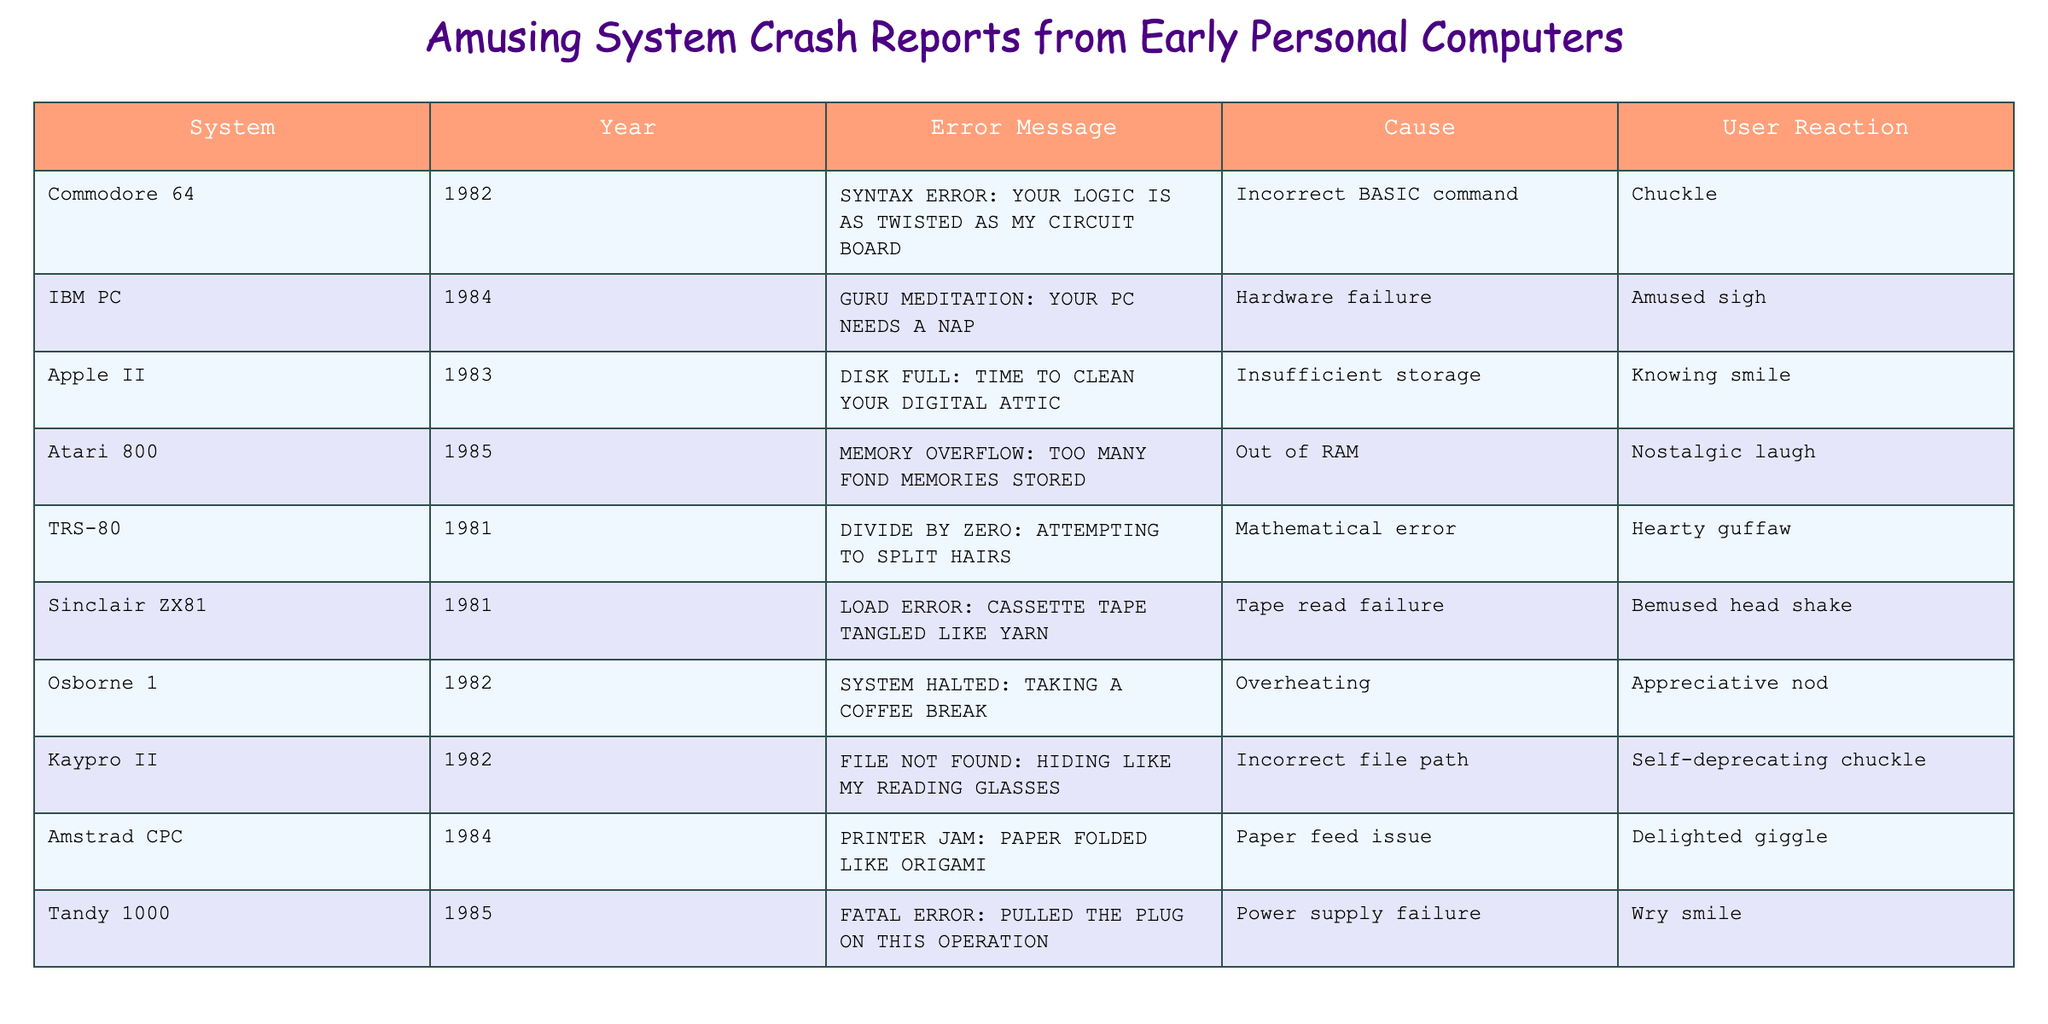What is the error message associated with the IBM PC? The table shows that the IBM PC has the error message "GURU MEDITATION: YOUR PC NEEDS A NAP."
Answer: GURU MEDITATION: YOUR PC NEEDS A NAP Which system reported a "DIVIDE BY ZERO" error? The table lists the TRS-80 as the system that reported a "DIVIDE BY ZERO" error.
Answer: TRS-80 How many error messages reference something related to memory? The error messages for Atari 800 and TRS-80 both reference memory issues, making a total of 2 messages.
Answer: 2 What is the cause of the error message "LOAD ERROR: CASSETTE TAPE TANGLED LIKE YARN"? The cause of this error message, according to the table, is a tape read failure.
Answer: Tape read failure Which system's error message suggests it "needs a nap"? The IBM PC's error message "GURU MEDITATION: YOUR PC NEEDS A NAP" suggests it needs a nap.
Answer: IBM PC Among the systems listed, which one has an error related to a lack of storage? The Apple II has the error message "DISK FULL: TIME TO CLEAN YOUR DIGITAL ATTIC," indicating a lack of storage.
Answer: Apple II Which error message implies a humorous comparison with reading glasses? The error message from the Kaypro II, "FILE NOT FOUND: HIDING LIKE MY READING GLASSES," makes a humorous comparison.
Answer: Kaypro II What percentage of systems have error messages that elicit a "chuckle" as a user reaction? Out of the 10 systems, 2 have error messages that elicit a "chuckle," leading to a percentage of (2/10) * 100 = 20%.
Answer: 20% Which error message puts a positive spin on a memory issue? The Atari 800's error message "MEMORY OVERFLOW: TOO MANY FOND MEMORIES STORED" puts a positive spin on a memory issue.
Answer: Atari 800 How many distinct user reactions are mentioned in the table? The table lists five distinct user reactions: Chuckle, Amused sigh, Knowing smile, Nostalgic laugh, and so on, making a total of 6.
Answer: 6 